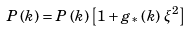<formula> <loc_0><loc_0><loc_500><loc_500>P \left ( { k } \right ) = P \left ( k \right ) \left [ 1 + g _ { * } \left ( k \right ) \, \xi ^ { 2 } \right ]</formula> 